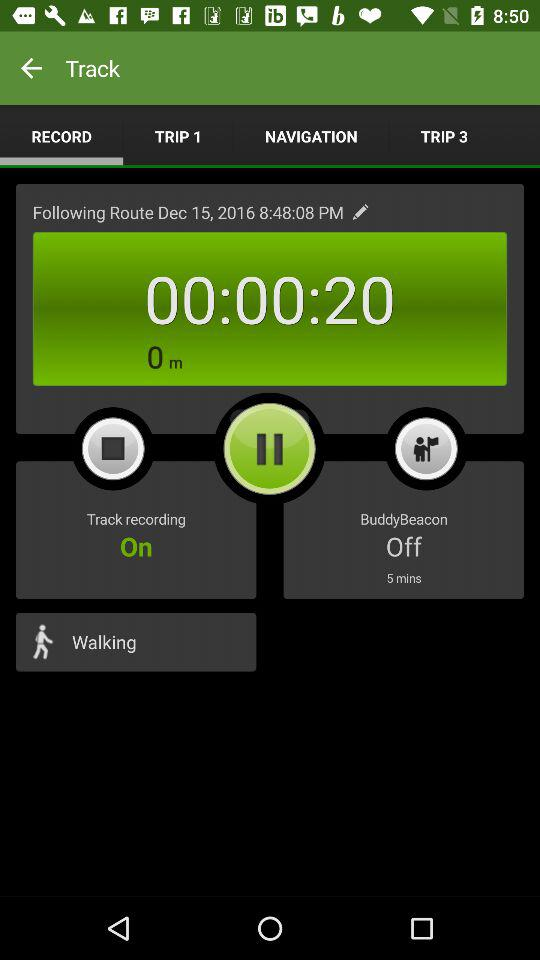How many minutes has the BuddyBeacon been off for?
Answer the question using a single word or phrase. 5 mins 